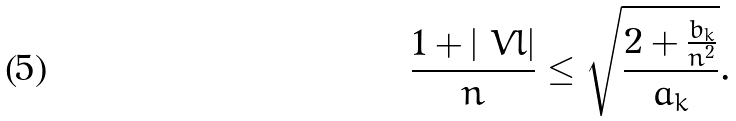Convert formula to latex. <formula><loc_0><loc_0><loc_500><loc_500>\frac { 1 + | \ V l | } n \leq \sqrt { \frac { 2 + \frac { b _ { k } } { n ^ { 2 } } } { a _ { k } } } .</formula> 